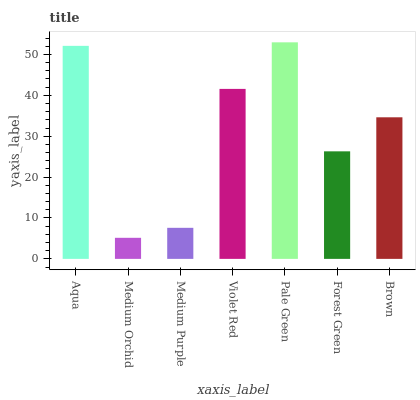Is Medium Purple the minimum?
Answer yes or no. No. Is Medium Purple the maximum?
Answer yes or no. No. Is Medium Purple greater than Medium Orchid?
Answer yes or no. Yes. Is Medium Orchid less than Medium Purple?
Answer yes or no. Yes. Is Medium Orchid greater than Medium Purple?
Answer yes or no. No. Is Medium Purple less than Medium Orchid?
Answer yes or no. No. Is Brown the high median?
Answer yes or no. Yes. Is Brown the low median?
Answer yes or no. Yes. Is Aqua the high median?
Answer yes or no. No. Is Forest Green the low median?
Answer yes or no. No. 